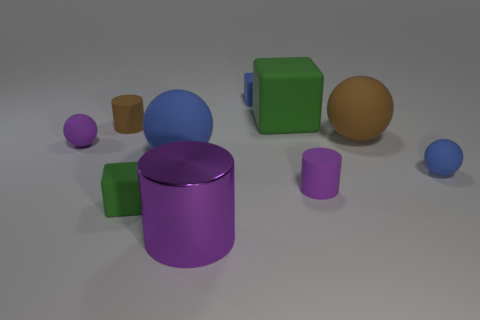There is a matte sphere that is the same color as the metallic cylinder; what size is it?
Ensure brevity in your answer.  Small. What shape is the matte thing that is the same color as the large rubber block?
Keep it short and to the point. Cube. The brown rubber cylinder is what size?
Your answer should be compact. Small. How many yellow objects are either big rubber balls or big rubber blocks?
Your response must be concise. 0. What number of purple things have the same shape as the small brown matte object?
Your response must be concise. 2. What number of other purple objects are the same size as the purple metallic thing?
Your answer should be very brief. 0. There is a large purple object that is the same shape as the small brown rubber object; what is its material?
Give a very brief answer. Metal. What is the color of the cylinder that is behind the large brown matte sphere?
Provide a succinct answer. Brown. Are there more green rubber objects behind the brown matte cylinder than small yellow spheres?
Your answer should be very brief. Yes. The big metallic cylinder has what color?
Keep it short and to the point. Purple. 